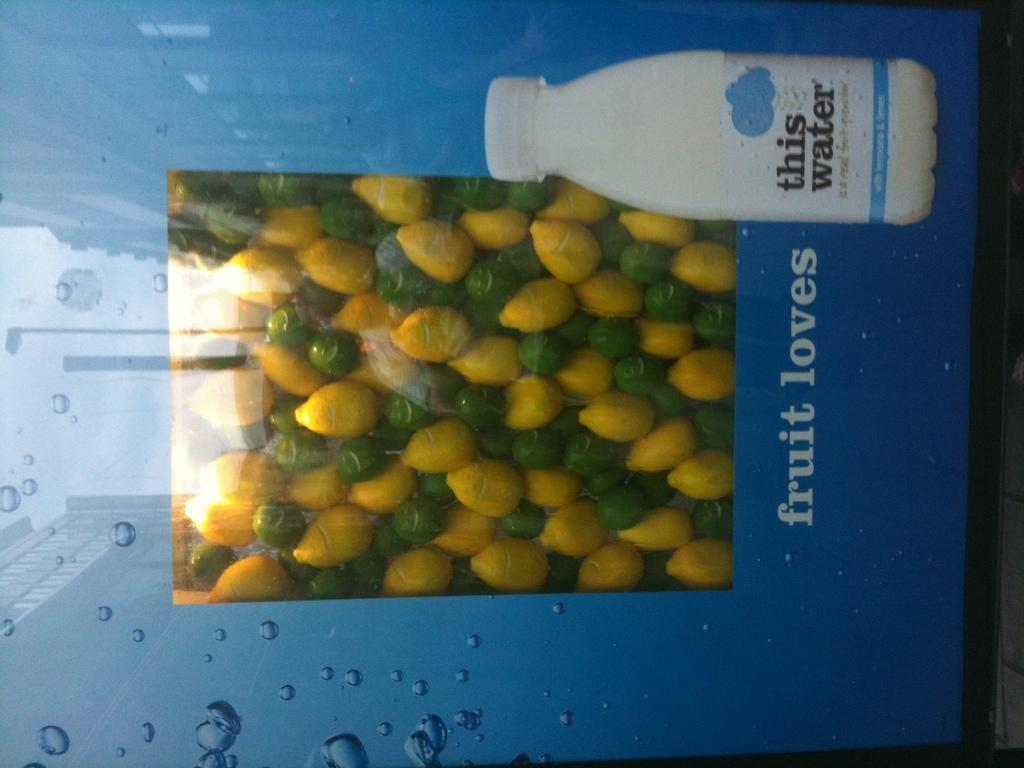What can be seen in the image that is typically used for holding liquids? There is a bottle in the image. What else is present in the image besides the bottle? There are unspecified things, buildings, a pole, water drops, and text on an advertisement in the image. Can you describe the type of structures visible in the image? There are buildings in the image. What is the condition of the water in the image? Water drops are visible in the image. What is written on the advertisement in the image? The text on the advertisement cannot be determined from the provided facts. What type of blade is being used by the committee in the image? There is no committee or blade present in the image. What type of servant is shown attending to the needs of the people in the image? There is no servant present in the image. 